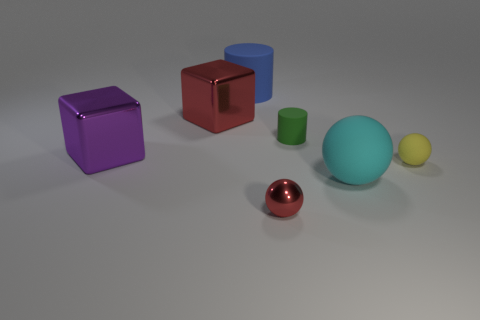The rubber thing that is on the left side of the big rubber sphere and to the right of the big blue rubber thing is what color?
Offer a terse response. Green. What color is the shiny block that is on the left side of the red metal object that is to the left of the metal object right of the big blue object?
Ensure brevity in your answer.  Purple. There is a cylinder that is the same size as the yellow matte ball; what is its color?
Your answer should be compact. Green. The red metallic thing on the right side of the matte thing on the left side of the matte cylinder in front of the blue rubber cylinder is what shape?
Your answer should be compact. Sphere. The big object that is the same color as the small metal sphere is what shape?
Your answer should be compact. Cube. How many things are big matte balls or matte objects behind the large cyan matte ball?
Provide a short and direct response. 4. Is the size of the cylinder that is to the right of the red metallic sphere the same as the large purple object?
Make the answer very short. No. There is a red thing that is to the left of the small metallic object; what material is it?
Make the answer very short. Metal. Are there the same number of big matte things that are in front of the big matte cylinder and big matte spheres that are on the left side of the small red ball?
Offer a terse response. No. The other small thing that is the same shape as the blue rubber object is what color?
Offer a very short reply. Green. 